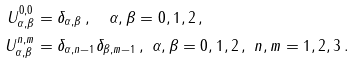Convert formula to latex. <formula><loc_0><loc_0><loc_500><loc_500>U ^ { 0 , 0 } _ { \alpha , \beta } & = \delta _ { \alpha , \beta } \, , \quad \alpha , \beta = 0 , 1 , 2 \, , \\ U ^ { n , m } _ { \alpha , \beta } & = \delta _ { \alpha , n - 1 } \delta _ { \beta , m - 1 } \, , \ \alpha , \beta = 0 , 1 , 2 \, , \ n , m = 1 , 2 , 3 \, .</formula> 